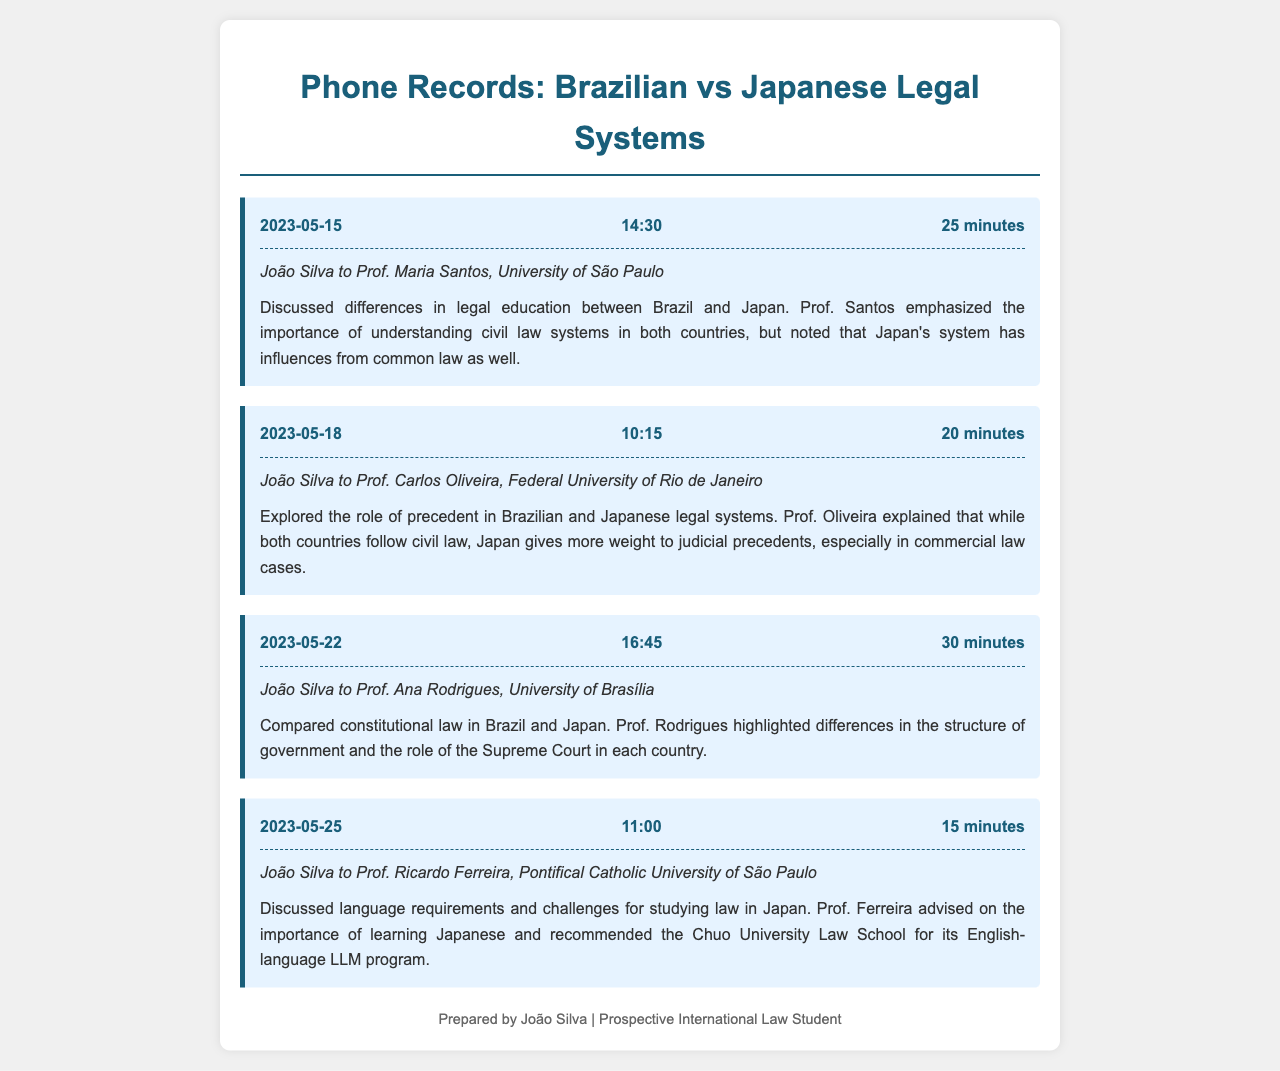What is the date of the first phone call? The first phone call occurred on May 15, 2023.
Answer: May 15, 2023 Who was João Silva speaking with on May 22, 2023? On May 22, 2023, João Silva spoke with Prof. Ana Rodrigues.
Answer: Prof. Ana Rodrigues How long did the call with Prof. Carlos Oliveira last? The call with Prof. Carlos Oliveira lasted 20 minutes.
Answer: 20 minutes What did Prof. Ferreira recommend for studying law in Japan? Prof. Ferreira recommended the Chuo University Law School for its English-language LLM program.
Answer: Chuo University Law School How many minutes did the call on constitutional law take? The call on constitutional law lasted for 30 minutes.
Answer: 30 minutes Which legal system does Japan give more weight to in judicial precedents? Japan gives more weight to judicial precedents in commercial law cases.
Answer: commercial law What is one major difference in government structure mentioned by Prof. Rodrigues? Prof. Rodrigues highlighted differences in the structure of government.
Answer: structure of government What is a common theme discussed across the phone calls? A common theme discussed is the differences between Brazilian and Japanese legal systems.
Answer: differences between Brazilian and Japanese legal systems 